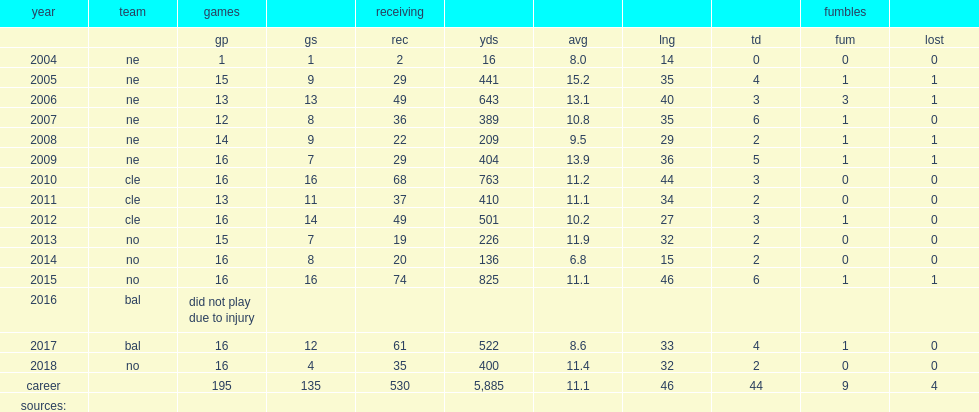How many receptions did watson finish 2014 season with? 20.0. 